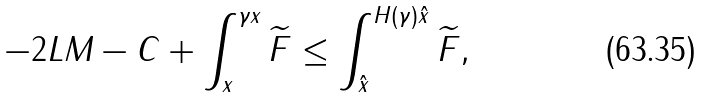<formula> <loc_0><loc_0><loc_500><loc_500>- 2 L M - C + \int _ { x } ^ { \gamma x } \widetilde { F } \leq \int _ { \hat { x } } ^ { H ( \gamma ) \hat { x } } \widetilde { F } ,</formula> 